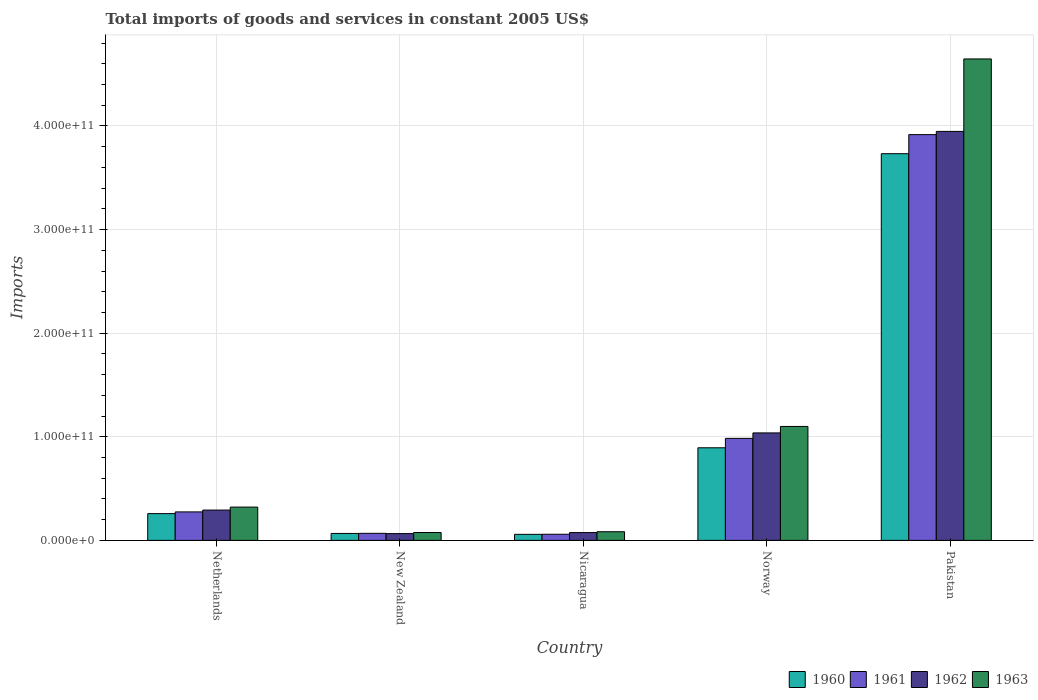How many different coloured bars are there?
Offer a terse response. 4. How many groups of bars are there?
Offer a very short reply. 5. Are the number of bars per tick equal to the number of legend labels?
Provide a short and direct response. Yes. Are the number of bars on each tick of the X-axis equal?
Provide a short and direct response. Yes. How many bars are there on the 5th tick from the right?
Make the answer very short. 4. In how many cases, is the number of bars for a given country not equal to the number of legend labels?
Your response must be concise. 0. What is the total imports of goods and services in 1962 in Pakistan?
Offer a very short reply. 3.95e+11. Across all countries, what is the maximum total imports of goods and services in 1963?
Make the answer very short. 4.65e+11. Across all countries, what is the minimum total imports of goods and services in 1960?
Offer a very short reply. 5.84e+09. In which country was the total imports of goods and services in 1960 maximum?
Give a very brief answer. Pakistan. In which country was the total imports of goods and services in 1960 minimum?
Your answer should be compact. Nicaragua. What is the total total imports of goods and services in 1962 in the graph?
Keep it short and to the point. 5.42e+11. What is the difference between the total imports of goods and services in 1960 in Netherlands and that in Nicaragua?
Keep it short and to the point. 2.00e+1. What is the difference between the total imports of goods and services in 1961 in Netherlands and the total imports of goods and services in 1963 in Pakistan?
Give a very brief answer. -4.37e+11. What is the average total imports of goods and services in 1961 per country?
Keep it short and to the point. 1.06e+11. What is the difference between the total imports of goods and services of/in 1961 and total imports of goods and services of/in 1962 in Nicaragua?
Provide a succinct answer. -1.61e+09. What is the ratio of the total imports of goods and services in 1961 in Nicaragua to that in Norway?
Offer a very short reply. 0.06. What is the difference between the highest and the second highest total imports of goods and services in 1961?
Make the answer very short. -7.10e+1. What is the difference between the highest and the lowest total imports of goods and services in 1960?
Keep it short and to the point. 3.67e+11. Is it the case that in every country, the sum of the total imports of goods and services in 1961 and total imports of goods and services in 1960 is greater than the sum of total imports of goods and services in 1963 and total imports of goods and services in 1962?
Offer a terse response. No. What does the 3rd bar from the left in Norway represents?
Offer a very short reply. 1962. What is the difference between two consecutive major ticks on the Y-axis?
Give a very brief answer. 1.00e+11. Are the values on the major ticks of Y-axis written in scientific E-notation?
Provide a succinct answer. Yes. Where does the legend appear in the graph?
Give a very brief answer. Bottom right. How many legend labels are there?
Provide a succinct answer. 4. What is the title of the graph?
Provide a succinct answer. Total imports of goods and services in constant 2005 US$. Does "1960" appear as one of the legend labels in the graph?
Your answer should be compact. Yes. What is the label or title of the Y-axis?
Your response must be concise. Imports. What is the Imports in 1960 in Netherlands?
Provide a short and direct response. 2.58e+1. What is the Imports in 1961 in Netherlands?
Offer a very short reply. 2.75e+1. What is the Imports in 1962 in Netherlands?
Offer a terse response. 2.93e+1. What is the Imports in 1963 in Netherlands?
Make the answer very short. 3.21e+1. What is the Imports of 1960 in New Zealand?
Your answer should be compact. 6.71e+09. What is the Imports in 1961 in New Zealand?
Offer a very short reply. 6.81e+09. What is the Imports of 1962 in New Zealand?
Offer a terse response. 6.55e+09. What is the Imports in 1963 in New Zealand?
Make the answer very short. 7.62e+09. What is the Imports of 1960 in Nicaragua?
Your response must be concise. 5.84e+09. What is the Imports of 1961 in Nicaragua?
Keep it short and to the point. 5.92e+09. What is the Imports of 1962 in Nicaragua?
Offer a terse response. 7.54e+09. What is the Imports of 1963 in Nicaragua?
Offer a terse response. 8.36e+09. What is the Imports in 1960 in Norway?
Keep it short and to the point. 8.94e+1. What is the Imports of 1961 in Norway?
Your answer should be compact. 9.85e+1. What is the Imports of 1962 in Norway?
Give a very brief answer. 1.04e+11. What is the Imports in 1963 in Norway?
Ensure brevity in your answer.  1.10e+11. What is the Imports of 1960 in Pakistan?
Provide a succinct answer. 3.73e+11. What is the Imports in 1961 in Pakistan?
Provide a short and direct response. 3.92e+11. What is the Imports of 1962 in Pakistan?
Offer a very short reply. 3.95e+11. What is the Imports in 1963 in Pakistan?
Provide a short and direct response. 4.65e+11. Across all countries, what is the maximum Imports of 1960?
Ensure brevity in your answer.  3.73e+11. Across all countries, what is the maximum Imports of 1961?
Make the answer very short. 3.92e+11. Across all countries, what is the maximum Imports in 1962?
Your answer should be compact. 3.95e+11. Across all countries, what is the maximum Imports of 1963?
Your response must be concise. 4.65e+11. Across all countries, what is the minimum Imports of 1960?
Give a very brief answer. 5.84e+09. Across all countries, what is the minimum Imports in 1961?
Your answer should be very brief. 5.92e+09. Across all countries, what is the minimum Imports of 1962?
Offer a very short reply. 6.55e+09. Across all countries, what is the minimum Imports of 1963?
Your answer should be compact. 7.62e+09. What is the total Imports in 1960 in the graph?
Your response must be concise. 5.01e+11. What is the total Imports of 1961 in the graph?
Offer a terse response. 5.30e+11. What is the total Imports of 1962 in the graph?
Make the answer very short. 5.42e+11. What is the total Imports of 1963 in the graph?
Give a very brief answer. 6.23e+11. What is the difference between the Imports of 1960 in Netherlands and that in New Zealand?
Provide a short and direct response. 1.91e+1. What is the difference between the Imports of 1961 in Netherlands and that in New Zealand?
Provide a short and direct response. 2.07e+1. What is the difference between the Imports of 1962 in Netherlands and that in New Zealand?
Give a very brief answer. 2.27e+1. What is the difference between the Imports of 1963 in Netherlands and that in New Zealand?
Your answer should be compact. 2.45e+1. What is the difference between the Imports of 1960 in Netherlands and that in Nicaragua?
Provide a succinct answer. 2.00e+1. What is the difference between the Imports of 1961 in Netherlands and that in Nicaragua?
Give a very brief answer. 2.16e+1. What is the difference between the Imports of 1962 in Netherlands and that in Nicaragua?
Keep it short and to the point. 2.17e+1. What is the difference between the Imports in 1963 in Netherlands and that in Nicaragua?
Keep it short and to the point. 2.38e+1. What is the difference between the Imports of 1960 in Netherlands and that in Norway?
Provide a succinct answer. -6.35e+1. What is the difference between the Imports of 1961 in Netherlands and that in Norway?
Make the answer very short. -7.10e+1. What is the difference between the Imports in 1962 in Netherlands and that in Norway?
Provide a succinct answer. -7.45e+1. What is the difference between the Imports of 1963 in Netherlands and that in Norway?
Offer a very short reply. -7.78e+1. What is the difference between the Imports of 1960 in Netherlands and that in Pakistan?
Provide a succinct answer. -3.47e+11. What is the difference between the Imports in 1961 in Netherlands and that in Pakistan?
Provide a succinct answer. -3.64e+11. What is the difference between the Imports of 1962 in Netherlands and that in Pakistan?
Make the answer very short. -3.66e+11. What is the difference between the Imports in 1963 in Netherlands and that in Pakistan?
Your response must be concise. -4.33e+11. What is the difference between the Imports in 1960 in New Zealand and that in Nicaragua?
Provide a short and direct response. 8.66e+08. What is the difference between the Imports of 1961 in New Zealand and that in Nicaragua?
Make the answer very short. 8.81e+08. What is the difference between the Imports in 1962 in New Zealand and that in Nicaragua?
Your answer should be compact. -9.91e+08. What is the difference between the Imports in 1963 in New Zealand and that in Nicaragua?
Your answer should be very brief. -7.46e+08. What is the difference between the Imports of 1960 in New Zealand and that in Norway?
Offer a terse response. -8.27e+1. What is the difference between the Imports of 1961 in New Zealand and that in Norway?
Provide a succinct answer. -9.17e+1. What is the difference between the Imports of 1962 in New Zealand and that in Norway?
Ensure brevity in your answer.  -9.72e+1. What is the difference between the Imports of 1963 in New Zealand and that in Norway?
Provide a short and direct response. -1.02e+11. What is the difference between the Imports of 1960 in New Zealand and that in Pakistan?
Your answer should be compact. -3.67e+11. What is the difference between the Imports of 1961 in New Zealand and that in Pakistan?
Ensure brevity in your answer.  -3.85e+11. What is the difference between the Imports of 1962 in New Zealand and that in Pakistan?
Keep it short and to the point. -3.88e+11. What is the difference between the Imports of 1963 in New Zealand and that in Pakistan?
Your answer should be very brief. -4.57e+11. What is the difference between the Imports of 1960 in Nicaragua and that in Norway?
Your answer should be very brief. -8.35e+1. What is the difference between the Imports of 1961 in Nicaragua and that in Norway?
Offer a very short reply. -9.25e+1. What is the difference between the Imports in 1962 in Nicaragua and that in Norway?
Ensure brevity in your answer.  -9.62e+1. What is the difference between the Imports in 1963 in Nicaragua and that in Norway?
Give a very brief answer. -1.02e+11. What is the difference between the Imports of 1960 in Nicaragua and that in Pakistan?
Your answer should be compact. -3.67e+11. What is the difference between the Imports of 1961 in Nicaragua and that in Pakistan?
Your response must be concise. -3.86e+11. What is the difference between the Imports in 1962 in Nicaragua and that in Pakistan?
Your response must be concise. -3.87e+11. What is the difference between the Imports in 1963 in Nicaragua and that in Pakistan?
Your response must be concise. -4.56e+11. What is the difference between the Imports of 1960 in Norway and that in Pakistan?
Your answer should be compact. -2.84e+11. What is the difference between the Imports of 1961 in Norway and that in Pakistan?
Offer a very short reply. -2.93e+11. What is the difference between the Imports of 1962 in Norway and that in Pakistan?
Provide a short and direct response. -2.91e+11. What is the difference between the Imports of 1963 in Norway and that in Pakistan?
Keep it short and to the point. -3.55e+11. What is the difference between the Imports in 1960 in Netherlands and the Imports in 1961 in New Zealand?
Give a very brief answer. 1.90e+1. What is the difference between the Imports of 1960 in Netherlands and the Imports of 1962 in New Zealand?
Ensure brevity in your answer.  1.93e+1. What is the difference between the Imports in 1960 in Netherlands and the Imports in 1963 in New Zealand?
Give a very brief answer. 1.82e+1. What is the difference between the Imports in 1961 in Netherlands and the Imports in 1962 in New Zealand?
Offer a terse response. 2.10e+1. What is the difference between the Imports in 1961 in Netherlands and the Imports in 1963 in New Zealand?
Your response must be concise. 1.99e+1. What is the difference between the Imports in 1962 in Netherlands and the Imports in 1963 in New Zealand?
Offer a very short reply. 2.17e+1. What is the difference between the Imports in 1960 in Netherlands and the Imports in 1961 in Nicaragua?
Make the answer very short. 1.99e+1. What is the difference between the Imports in 1960 in Netherlands and the Imports in 1962 in Nicaragua?
Offer a very short reply. 1.83e+1. What is the difference between the Imports of 1960 in Netherlands and the Imports of 1963 in Nicaragua?
Give a very brief answer. 1.75e+1. What is the difference between the Imports of 1961 in Netherlands and the Imports of 1962 in Nicaragua?
Your answer should be very brief. 2.00e+1. What is the difference between the Imports of 1961 in Netherlands and the Imports of 1963 in Nicaragua?
Make the answer very short. 1.91e+1. What is the difference between the Imports of 1962 in Netherlands and the Imports of 1963 in Nicaragua?
Ensure brevity in your answer.  2.09e+1. What is the difference between the Imports in 1960 in Netherlands and the Imports in 1961 in Norway?
Provide a succinct answer. -7.26e+1. What is the difference between the Imports of 1960 in Netherlands and the Imports of 1962 in Norway?
Offer a very short reply. -7.79e+1. What is the difference between the Imports of 1960 in Netherlands and the Imports of 1963 in Norway?
Provide a succinct answer. -8.41e+1. What is the difference between the Imports in 1961 in Netherlands and the Imports in 1962 in Norway?
Provide a succinct answer. -7.62e+1. What is the difference between the Imports of 1961 in Netherlands and the Imports of 1963 in Norway?
Your response must be concise. -8.25e+1. What is the difference between the Imports in 1962 in Netherlands and the Imports in 1963 in Norway?
Provide a short and direct response. -8.07e+1. What is the difference between the Imports of 1960 in Netherlands and the Imports of 1961 in Pakistan?
Give a very brief answer. -3.66e+11. What is the difference between the Imports of 1960 in Netherlands and the Imports of 1962 in Pakistan?
Offer a very short reply. -3.69e+11. What is the difference between the Imports in 1960 in Netherlands and the Imports in 1963 in Pakistan?
Give a very brief answer. -4.39e+11. What is the difference between the Imports of 1961 in Netherlands and the Imports of 1962 in Pakistan?
Provide a succinct answer. -3.67e+11. What is the difference between the Imports in 1961 in Netherlands and the Imports in 1963 in Pakistan?
Provide a short and direct response. -4.37e+11. What is the difference between the Imports in 1962 in Netherlands and the Imports in 1963 in Pakistan?
Your answer should be compact. -4.35e+11. What is the difference between the Imports in 1960 in New Zealand and the Imports in 1961 in Nicaragua?
Provide a succinct answer. 7.83e+08. What is the difference between the Imports in 1960 in New Zealand and the Imports in 1962 in Nicaragua?
Ensure brevity in your answer.  -8.30e+08. What is the difference between the Imports in 1960 in New Zealand and the Imports in 1963 in Nicaragua?
Keep it short and to the point. -1.66e+09. What is the difference between the Imports in 1961 in New Zealand and the Imports in 1962 in Nicaragua?
Offer a terse response. -7.32e+08. What is the difference between the Imports of 1961 in New Zealand and the Imports of 1963 in Nicaragua?
Ensure brevity in your answer.  -1.56e+09. What is the difference between the Imports of 1962 in New Zealand and the Imports of 1963 in Nicaragua?
Provide a short and direct response. -1.82e+09. What is the difference between the Imports in 1960 in New Zealand and the Imports in 1961 in Norway?
Give a very brief answer. -9.18e+1. What is the difference between the Imports of 1960 in New Zealand and the Imports of 1962 in Norway?
Ensure brevity in your answer.  -9.70e+1. What is the difference between the Imports of 1960 in New Zealand and the Imports of 1963 in Norway?
Keep it short and to the point. -1.03e+11. What is the difference between the Imports of 1961 in New Zealand and the Imports of 1962 in Norway?
Provide a succinct answer. -9.69e+1. What is the difference between the Imports of 1961 in New Zealand and the Imports of 1963 in Norway?
Your answer should be very brief. -1.03e+11. What is the difference between the Imports of 1962 in New Zealand and the Imports of 1963 in Norway?
Give a very brief answer. -1.03e+11. What is the difference between the Imports in 1960 in New Zealand and the Imports in 1961 in Pakistan?
Make the answer very short. -3.85e+11. What is the difference between the Imports in 1960 in New Zealand and the Imports in 1962 in Pakistan?
Give a very brief answer. -3.88e+11. What is the difference between the Imports in 1960 in New Zealand and the Imports in 1963 in Pakistan?
Keep it short and to the point. -4.58e+11. What is the difference between the Imports in 1961 in New Zealand and the Imports in 1962 in Pakistan?
Make the answer very short. -3.88e+11. What is the difference between the Imports in 1961 in New Zealand and the Imports in 1963 in Pakistan?
Offer a terse response. -4.58e+11. What is the difference between the Imports of 1962 in New Zealand and the Imports of 1963 in Pakistan?
Give a very brief answer. -4.58e+11. What is the difference between the Imports in 1960 in Nicaragua and the Imports in 1961 in Norway?
Offer a very short reply. -9.26e+1. What is the difference between the Imports in 1960 in Nicaragua and the Imports in 1962 in Norway?
Your response must be concise. -9.79e+1. What is the difference between the Imports in 1960 in Nicaragua and the Imports in 1963 in Norway?
Provide a succinct answer. -1.04e+11. What is the difference between the Imports of 1961 in Nicaragua and the Imports of 1962 in Norway?
Your response must be concise. -9.78e+1. What is the difference between the Imports in 1961 in Nicaragua and the Imports in 1963 in Norway?
Ensure brevity in your answer.  -1.04e+11. What is the difference between the Imports in 1962 in Nicaragua and the Imports in 1963 in Norway?
Provide a short and direct response. -1.02e+11. What is the difference between the Imports of 1960 in Nicaragua and the Imports of 1961 in Pakistan?
Your response must be concise. -3.86e+11. What is the difference between the Imports of 1960 in Nicaragua and the Imports of 1962 in Pakistan?
Offer a terse response. -3.89e+11. What is the difference between the Imports in 1960 in Nicaragua and the Imports in 1963 in Pakistan?
Provide a short and direct response. -4.59e+11. What is the difference between the Imports of 1961 in Nicaragua and the Imports of 1962 in Pakistan?
Keep it short and to the point. -3.89e+11. What is the difference between the Imports in 1961 in Nicaragua and the Imports in 1963 in Pakistan?
Your answer should be compact. -4.59e+11. What is the difference between the Imports of 1962 in Nicaragua and the Imports of 1963 in Pakistan?
Ensure brevity in your answer.  -4.57e+11. What is the difference between the Imports in 1960 in Norway and the Imports in 1961 in Pakistan?
Offer a very short reply. -3.02e+11. What is the difference between the Imports of 1960 in Norway and the Imports of 1962 in Pakistan?
Make the answer very short. -3.05e+11. What is the difference between the Imports in 1960 in Norway and the Imports in 1963 in Pakistan?
Offer a terse response. -3.75e+11. What is the difference between the Imports of 1961 in Norway and the Imports of 1962 in Pakistan?
Offer a terse response. -2.96e+11. What is the difference between the Imports of 1961 in Norway and the Imports of 1963 in Pakistan?
Provide a short and direct response. -3.66e+11. What is the difference between the Imports of 1962 in Norway and the Imports of 1963 in Pakistan?
Give a very brief answer. -3.61e+11. What is the average Imports of 1960 per country?
Make the answer very short. 1.00e+11. What is the average Imports in 1961 per country?
Your response must be concise. 1.06e+11. What is the average Imports of 1962 per country?
Make the answer very short. 1.08e+11. What is the average Imports in 1963 per country?
Keep it short and to the point. 1.25e+11. What is the difference between the Imports in 1960 and Imports in 1961 in Netherlands?
Your response must be concise. -1.65e+09. What is the difference between the Imports of 1960 and Imports of 1962 in Netherlands?
Keep it short and to the point. -3.43e+09. What is the difference between the Imports of 1960 and Imports of 1963 in Netherlands?
Your response must be concise. -6.30e+09. What is the difference between the Imports of 1961 and Imports of 1962 in Netherlands?
Your answer should be compact. -1.77e+09. What is the difference between the Imports of 1961 and Imports of 1963 in Netherlands?
Offer a very short reply. -4.65e+09. What is the difference between the Imports of 1962 and Imports of 1963 in Netherlands?
Your answer should be very brief. -2.87e+09. What is the difference between the Imports of 1960 and Imports of 1961 in New Zealand?
Make the answer very short. -9.87e+07. What is the difference between the Imports of 1960 and Imports of 1962 in New Zealand?
Offer a very short reply. 1.61e+08. What is the difference between the Imports in 1960 and Imports in 1963 in New Zealand?
Provide a short and direct response. -9.09e+08. What is the difference between the Imports in 1961 and Imports in 1962 in New Zealand?
Give a very brief answer. 2.60e+08. What is the difference between the Imports in 1961 and Imports in 1963 in New Zealand?
Your response must be concise. -8.10e+08. What is the difference between the Imports in 1962 and Imports in 1963 in New Zealand?
Offer a terse response. -1.07e+09. What is the difference between the Imports in 1960 and Imports in 1961 in Nicaragua?
Provide a succinct answer. -8.34e+07. What is the difference between the Imports of 1960 and Imports of 1962 in Nicaragua?
Your response must be concise. -1.70e+09. What is the difference between the Imports of 1960 and Imports of 1963 in Nicaragua?
Your response must be concise. -2.52e+09. What is the difference between the Imports in 1961 and Imports in 1962 in Nicaragua?
Offer a terse response. -1.61e+09. What is the difference between the Imports of 1961 and Imports of 1963 in Nicaragua?
Make the answer very short. -2.44e+09. What is the difference between the Imports of 1962 and Imports of 1963 in Nicaragua?
Make the answer very short. -8.25e+08. What is the difference between the Imports in 1960 and Imports in 1961 in Norway?
Ensure brevity in your answer.  -9.07e+09. What is the difference between the Imports of 1960 and Imports of 1962 in Norway?
Offer a very short reply. -1.44e+1. What is the difference between the Imports of 1960 and Imports of 1963 in Norway?
Your answer should be very brief. -2.06e+1. What is the difference between the Imports in 1961 and Imports in 1962 in Norway?
Give a very brief answer. -5.28e+09. What is the difference between the Imports of 1961 and Imports of 1963 in Norway?
Provide a succinct answer. -1.15e+1. What is the difference between the Imports in 1962 and Imports in 1963 in Norway?
Provide a succinct answer. -6.24e+09. What is the difference between the Imports of 1960 and Imports of 1961 in Pakistan?
Provide a succinct answer. -1.84e+1. What is the difference between the Imports in 1960 and Imports in 1962 in Pakistan?
Your answer should be compact. -2.15e+1. What is the difference between the Imports of 1960 and Imports of 1963 in Pakistan?
Keep it short and to the point. -9.14e+1. What is the difference between the Imports in 1961 and Imports in 1962 in Pakistan?
Offer a very short reply. -3.12e+09. What is the difference between the Imports of 1961 and Imports of 1963 in Pakistan?
Make the answer very short. -7.30e+1. What is the difference between the Imports of 1962 and Imports of 1963 in Pakistan?
Your answer should be very brief. -6.99e+1. What is the ratio of the Imports in 1960 in Netherlands to that in New Zealand?
Your answer should be compact. 3.85. What is the ratio of the Imports of 1961 in Netherlands to that in New Zealand?
Offer a very short reply. 4.04. What is the ratio of the Imports of 1962 in Netherlands to that in New Zealand?
Ensure brevity in your answer.  4.47. What is the ratio of the Imports in 1963 in Netherlands to that in New Zealand?
Your answer should be compact. 4.22. What is the ratio of the Imports in 1960 in Netherlands to that in Nicaragua?
Your response must be concise. 4.42. What is the ratio of the Imports of 1961 in Netherlands to that in Nicaragua?
Your response must be concise. 4.64. What is the ratio of the Imports of 1962 in Netherlands to that in Nicaragua?
Give a very brief answer. 3.88. What is the ratio of the Imports in 1963 in Netherlands to that in Nicaragua?
Keep it short and to the point. 3.84. What is the ratio of the Imports in 1960 in Netherlands to that in Norway?
Give a very brief answer. 0.29. What is the ratio of the Imports of 1961 in Netherlands to that in Norway?
Provide a succinct answer. 0.28. What is the ratio of the Imports in 1962 in Netherlands to that in Norway?
Ensure brevity in your answer.  0.28. What is the ratio of the Imports of 1963 in Netherlands to that in Norway?
Keep it short and to the point. 0.29. What is the ratio of the Imports of 1960 in Netherlands to that in Pakistan?
Make the answer very short. 0.07. What is the ratio of the Imports of 1961 in Netherlands to that in Pakistan?
Your answer should be very brief. 0.07. What is the ratio of the Imports of 1962 in Netherlands to that in Pakistan?
Offer a terse response. 0.07. What is the ratio of the Imports in 1963 in Netherlands to that in Pakistan?
Give a very brief answer. 0.07. What is the ratio of the Imports in 1960 in New Zealand to that in Nicaragua?
Provide a succinct answer. 1.15. What is the ratio of the Imports in 1961 in New Zealand to that in Nicaragua?
Make the answer very short. 1.15. What is the ratio of the Imports in 1962 in New Zealand to that in Nicaragua?
Offer a very short reply. 0.87. What is the ratio of the Imports of 1963 in New Zealand to that in Nicaragua?
Provide a short and direct response. 0.91. What is the ratio of the Imports of 1960 in New Zealand to that in Norway?
Provide a succinct answer. 0.07. What is the ratio of the Imports of 1961 in New Zealand to that in Norway?
Keep it short and to the point. 0.07. What is the ratio of the Imports of 1962 in New Zealand to that in Norway?
Offer a terse response. 0.06. What is the ratio of the Imports of 1963 in New Zealand to that in Norway?
Keep it short and to the point. 0.07. What is the ratio of the Imports in 1960 in New Zealand to that in Pakistan?
Your answer should be compact. 0.02. What is the ratio of the Imports in 1961 in New Zealand to that in Pakistan?
Keep it short and to the point. 0.02. What is the ratio of the Imports in 1962 in New Zealand to that in Pakistan?
Provide a succinct answer. 0.02. What is the ratio of the Imports of 1963 in New Zealand to that in Pakistan?
Make the answer very short. 0.02. What is the ratio of the Imports of 1960 in Nicaragua to that in Norway?
Your response must be concise. 0.07. What is the ratio of the Imports in 1961 in Nicaragua to that in Norway?
Ensure brevity in your answer.  0.06. What is the ratio of the Imports of 1962 in Nicaragua to that in Norway?
Keep it short and to the point. 0.07. What is the ratio of the Imports in 1963 in Nicaragua to that in Norway?
Your answer should be compact. 0.08. What is the ratio of the Imports in 1960 in Nicaragua to that in Pakistan?
Provide a succinct answer. 0.02. What is the ratio of the Imports in 1961 in Nicaragua to that in Pakistan?
Give a very brief answer. 0.02. What is the ratio of the Imports of 1962 in Nicaragua to that in Pakistan?
Keep it short and to the point. 0.02. What is the ratio of the Imports in 1963 in Nicaragua to that in Pakistan?
Give a very brief answer. 0.02. What is the ratio of the Imports of 1960 in Norway to that in Pakistan?
Keep it short and to the point. 0.24. What is the ratio of the Imports in 1961 in Norway to that in Pakistan?
Offer a very short reply. 0.25. What is the ratio of the Imports in 1962 in Norway to that in Pakistan?
Your answer should be very brief. 0.26. What is the ratio of the Imports of 1963 in Norway to that in Pakistan?
Make the answer very short. 0.24. What is the difference between the highest and the second highest Imports of 1960?
Ensure brevity in your answer.  2.84e+11. What is the difference between the highest and the second highest Imports of 1961?
Give a very brief answer. 2.93e+11. What is the difference between the highest and the second highest Imports of 1962?
Give a very brief answer. 2.91e+11. What is the difference between the highest and the second highest Imports in 1963?
Your answer should be compact. 3.55e+11. What is the difference between the highest and the lowest Imports of 1960?
Make the answer very short. 3.67e+11. What is the difference between the highest and the lowest Imports in 1961?
Give a very brief answer. 3.86e+11. What is the difference between the highest and the lowest Imports in 1962?
Make the answer very short. 3.88e+11. What is the difference between the highest and the lowest Imports in 1963?
Keep it short and to the point. 4.57e+11. 